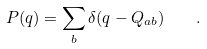Convert formula to latex. <formula><loc_0><loc_0><loc_500><loc_500>P ( q ) = \sum _ { b } \delta ( q - Q _ { a b } ) \quad .</formula> 